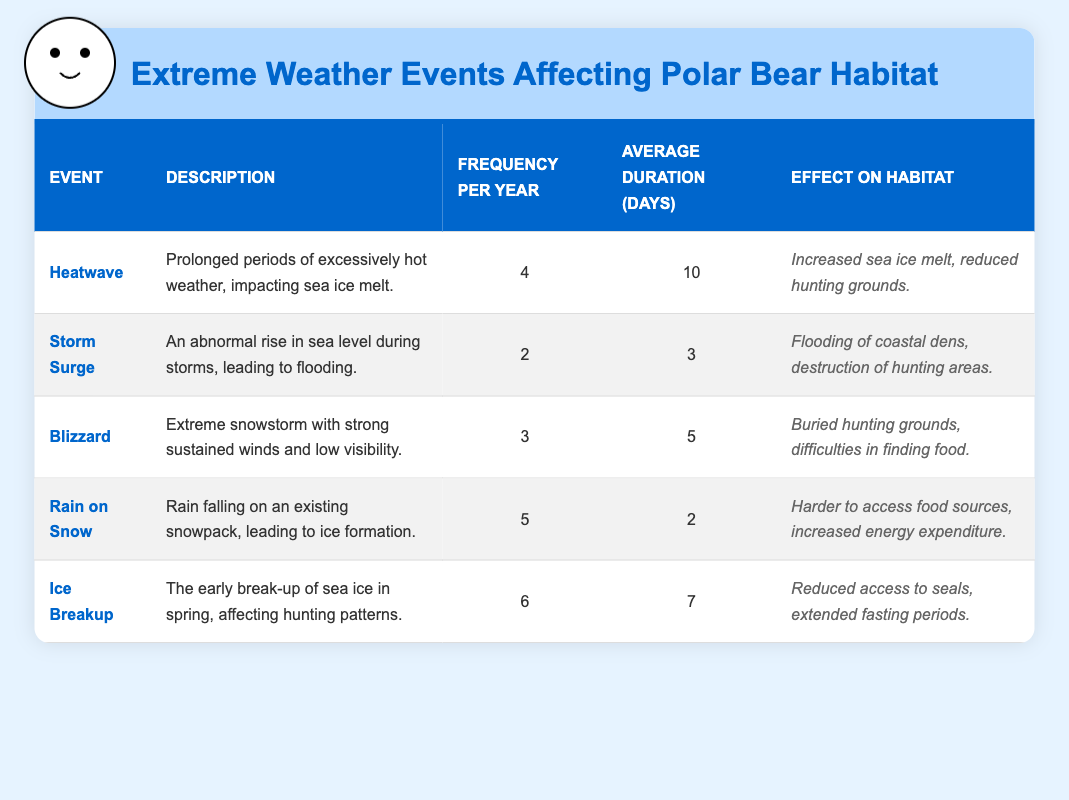What is the frequency per year of Heatwave events? The table lists "Heatwave" in the first row, and under the "Frequency per Year" column, the value is 4.
Answer: 4 What effect does a Blizzard have on polar bear habitat? In the table, the "Effect on Habitat" for "Blizzard" is described as "Buried hunting grounds, difficulties in finding food."
Answer: Buried hunting grounds, difficulties in finding food How many extreme weather events occur more than 4 times per year? By reviewing the "Frequency per Year" values, "Rain on Snow" (5), "Ice Breakup" (6), and "Heatwave" (4) are relevant. Only "Rain on Snow" and "Ice Breakup" exceed 4, making a total of 2 events.
Answer: 2 What is the average duration of all extreme weather events combined? To find the average duration, sum the "Average Duration (Days)" for all events (10 + 3 + 5 + 2 + 7 = 27) and divide by the number of events (5). Therefore, 27/5 = 5.4.
Answer: 5.4 Is the effect of Storm Surge on habitat positive? The table states the effect of "Storm Surge" as "Flooding of coastal dens, destruction of hunting areas," which implies a negative impact. Therefore, the proposed fact is false.
Answer: No 